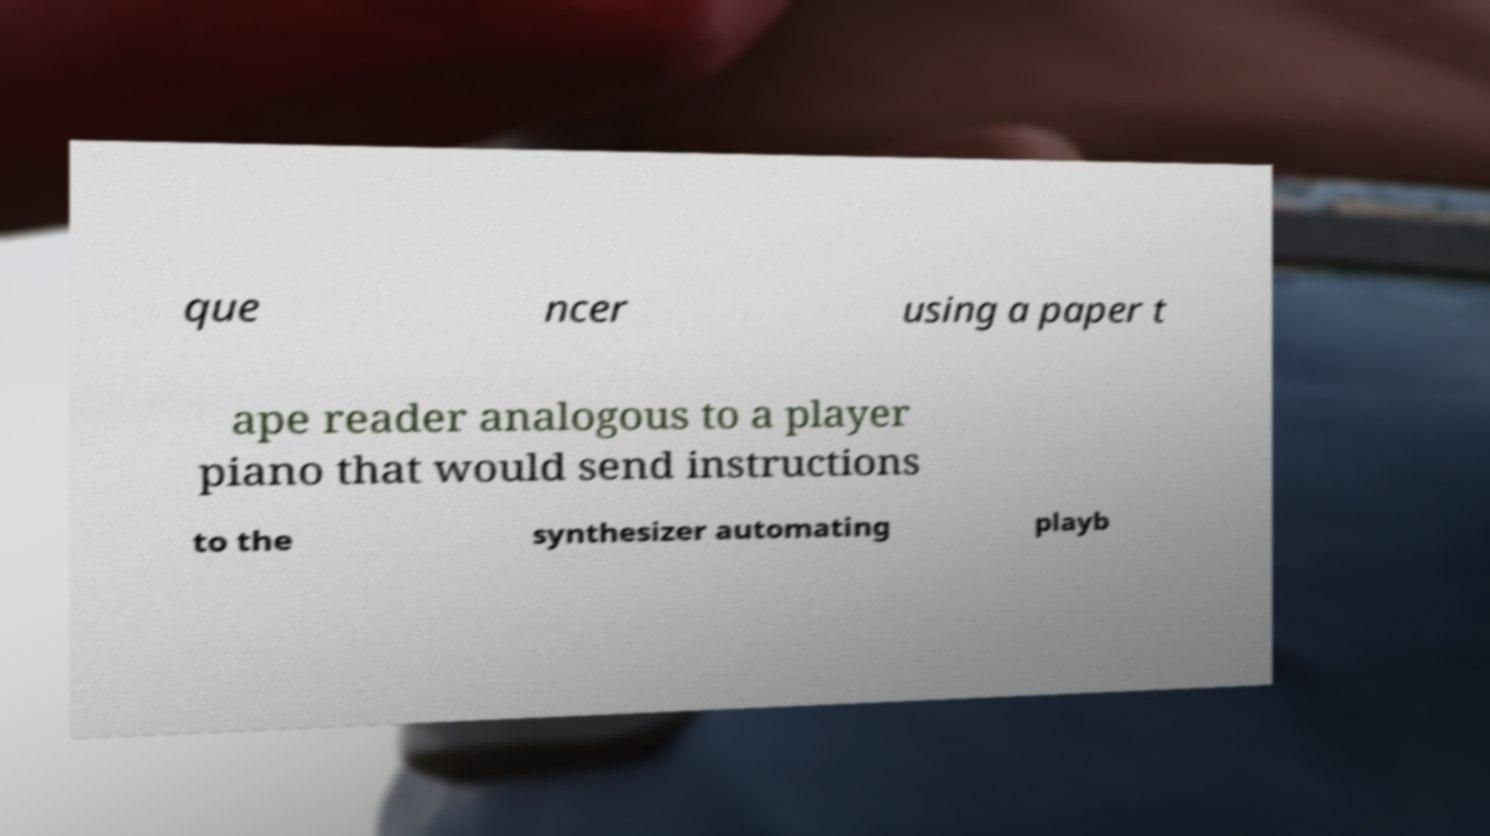Please identify and transcribe the text found in this image. que ncer using a paper t ape reader analogous to a player piano that would send instructions to the synthesizer automating playb 